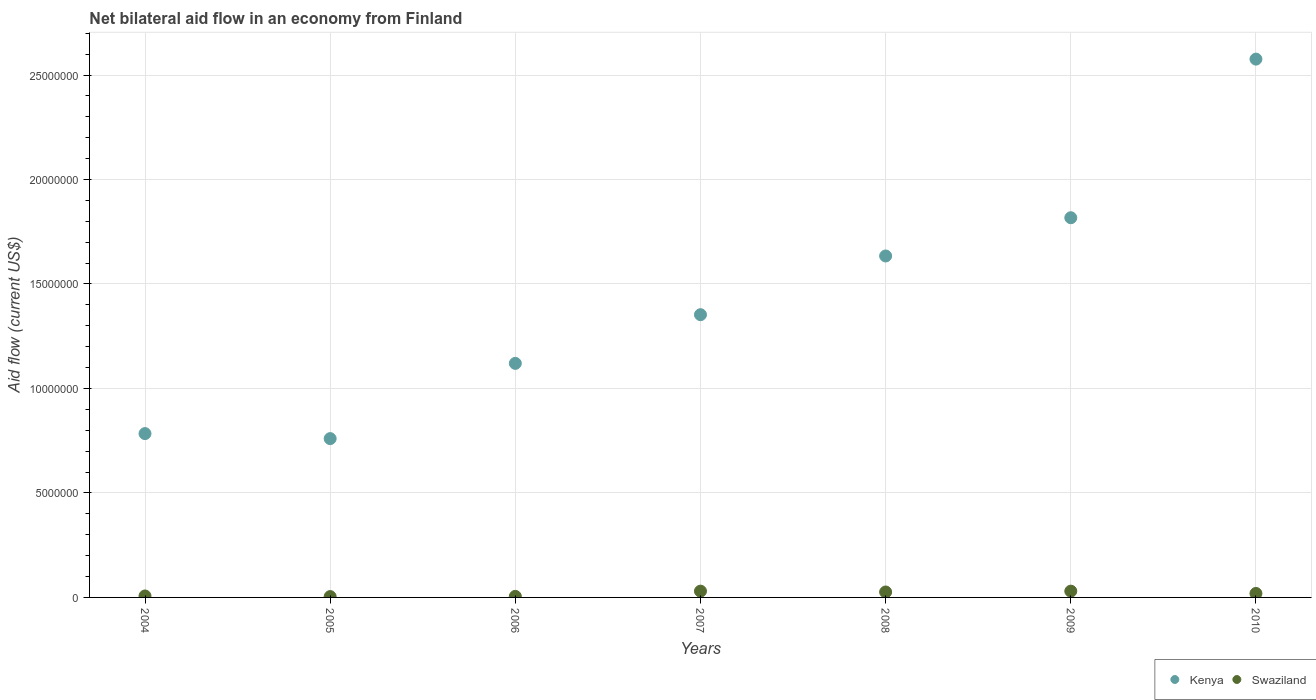Is the number of dotlines equal to the number of legend labels?
Provide a short and direct response. Yes. What is the net bilateral aid flow in Kenya in 2006?
Provide a succinct answer. 1.12e+07. Across all years, what is the minimum net bilateral aid flow in Kenya?
Provide a short and direct response. 7.60e+06. In which year was the net bilateral aid flow in Swaziland maximum?
Offer a terse response. 2007. What is the total net bilateral aid flow in Kenya in the graph?
Ensure brevity in your answer.  1.00e+08. What is the difference between the net bilateral aid flow in Swaziland in 2006 and that in 2008?
Ensure brevity in your answer.  -2.10e+05. What is the difference between the net bilateral aid flow in Kenya in 2005 and the net bilateral aid flow in Swaziland in 2010?
Your answer should be compact. 7.41e+06. What is the average net bilateral aid flow in Kenya per year?
Offer a very short reply. 1.43e+07. In the year 2010, what is the difference between the net bilateral aid flow in Kenya and net bilateral aid flow in Swaziland?
Your answer should be very brief. 2.56e+07. In how many years, is the net bilateral aid flow in Kenya greater than 19000000 US$?
Make the answer very short. 1. What is the ratio of the net bilateral aid flow in Swaziland in 2006 to that in 2010?
Make the answer very short. 0.26. Is the net bilateral aid flow in Kenya in 2005 less than that in 2010?
Offer a very short reply. Yes. Is the difference between the net bilateral aid flow in Kenya in 2007 and 2010 greater than the difference between the net bilateral aid flow in Swaziland in 2007 and 2010?
Offer a very short reply. No. What is the difference between the highest and the second highest net bilateral aid flow in Kenya?
Ensure brevity in your answer.  7.59e+06. What is the difference between the highest and the lowest net bilateral aid flow in Kenya?
Keep it short and to the point. 1.82e+07. In how many years, is the net bilateral aid flow in Swaziland greater than the average net bilateral aid flow in Swaziland taken over all years?
Offer a very short reply. 4. Is the sum of the net bilateral aid flow in Swaziland in 2005 and 2006 greater than the maximum net bilateral aid flow in Kenya across all years?
Your answer should be compact. No. Does the net bilateral aid flow in Kenya monotonically increase over the years?
Your answer should be compact. No. Is the net bilateral aid flow in Kenya strictly less than the net bilateral aid flow in Swaziland over the years?
Provide a succinct answer. No. How many dotlines are there?
Give a very brief answer. 2. Are the values on the major ticks of Y-axis written in scientific E-notation?
Your response must be concise. No. Does the graph contain any zero values?
Your answer should be very brief. No. How many legend labels are there?
Provide a short and direct response. 2. What is the title of the graph?
Make the answer very short. Net bilateral aid flow in an economy from Finland. What is the label or title of the X-axis?
Your answer should be very brief. Years. What is the label or title of the Y-axis?
Your answer should be very brief. Aid flow (current US$). What is the Aid flow (current US$) of Kenya in 2004?
Your response must be concise. 7.84e+06. What is the Aid flow (current US$) in Swaziland in 2004?
Give a very brief answer. 7.00e+04. What is the Aid flow (current US$) of Kenya in 2005?
Your answer should be compact. 7.60e+06. What is the Aid flow (current US$) in Swaziland in 2005?
Ensure brevity in your answer.  4.00e+04. What is the Aid flow (current US$) of Kenya in 2006?
Offer a terse response. 1.12e+07. What is the Aid flow (current US$) in Kenya in 2007?
Give a very brief answer. 1.35e+07. What is the Aid flow (current US$) of Kenya in 2008?
Offer a terse response. 1.63e+07. What is the Aid flow (current US$) in Swaziland in 2008?
Your response must be concise. 2.60e+05. What is the Aid flow (current US$) in Kenya in 2009?
Make the answer very short. 1.82e+07. What is the Aid flow (current US$) in Kenya in 2010?
Offer a very short reply. 2.58e+07. What is the Aid flow (current US$) of Swaziland in 2010?
Your response must be concise. 1.90e+05. Across all years, what is the maximum Aid flow (current US$) of Kenya?
Offer a very short reply. 2.58e+07. Across all years, what is the maximum Aid flow (current US$) of Swaziland?
Ensure brevity in your answer.  3.00e+05. Across all years, what is the minimum Aid flow (current US$) in Kenya?
Your response must be concise. 7.60e+06. What is the total Aid flow (current US$) of Kenya in the graph?
Keep it short and to the point. 1.00e+08. What is the total Aid flow (current US$) in Swaziland in the graph?
Ensure brevity in your answer.  1.21e+06. What is the difference between the Aid flow (current US$) in Kenya in 2004 and that in 2005?
Ensure brevity in your answer.  2.40e+05. What is the difference between the Aid flow (current US$) of Kenya in 2004 and that in 2006?
Offer a terse response. -3.36e+06. What is the difference between the Aid flow (current US$) of Kenya in 2004 and that in 2007?
Your response must be concise. -5.69e+06. What is the difference between the Aid flow (current US$) in Kenya in 2004 and that in 2008?
Give a very brief answer. -8.50e+06. What is the difference between the Aid flow (current US$) of Kenya in 2004 and that in 2009?
Offer a terse response. -1.03e+07. What is the difference between the Aid flow (current US$) of Swaziland in 2004 and that in 2009?
Your answer should be compact. -2.30e+05. What is the difference between the Aid flow (current US$) in Kenya in 2004 and that in 2010?
Provide a short and direct response. -1.79e+07. What is the difference between the Aid flow (current US$) in Swaziland in 2004 and that in 2010?
Your answer should be very brief. -1.20e+05. What is the difference between the Aid flow (current US$) of Kenya in 2005 and that in 2006?
Ensure brevity in your answer.  -3.60e+06. What is the difference between the Aid flow (current US$) of Swaziland in 2005 and that in 2006?
Provide a succinct answer. -10000. What is the difference between the Aid flow (current US$) in Kenya in 2005 and that in 2007?
Offer a terse response. -5.93e+06. What is the difference between the Aid flow (current US$) in Swaziland in 2005 and that in 2007?
Make the answer very short. -2.60e+05. What is the difference between the Aid flow (current US$) of Kenya in 2005 and that in 2008?
Give a very brief answer. -8.74e+06. What is the difference between the Aid flow (current US$) in Kenya in 2005 and that in 2009?
Offer a terse response. -1.06e+07. What is the difference between the Aid flow (current US$) in Kenya in 2005 and that in 2010?
Your answer should be compact. -1.82e+07. What is the difference between the Aid flow (current US$) of Kenya in 2006 and that in 2007?
Keep it short and to the point. -2.33e+06. What is the difference between the Aid flow (current US$) in Swaziland in 2006 and that in 2007?
Ensure brevity in your answer.  -2.50e+05. What is the difference between the Aid flow (current US$) of Kenya in 2006 and that in 2008?
Provide a succinct answer. -5.14e+06. What is the difference between the Aid flow (current US$) of Swaziland in 2006 and that in 2008?
Your answer should be very brief. -2.10e+05. What is the difference between the Aid flow (current US$) of Kenya in 2006 and that in 2009?
Give a very brief answer. -6.97e+06. What is the difference between the Aid flow (current US$) in Kenya in 2006 and that in 2010?
Offer a terse response. -1.46e+07. What is the difference between the Aid flow (current US$) of Kenya in 2007 and that in 2008?
Give a very brief answer. -2.81e+06. What is the difference between the Aid flow (current US$) in Swaziland in 2007 and that in 2008?
Give a very brief answer. 4.00e+04. What is the difference between the Aid flow (current US$) of Kenya in 2007 and that in 2009?
Ensure brevity in your answer.  -4.64e+06. What is the difference between the Aid flow (current US$) of Swaziland in 2007 and that in 2009?
Offer a very short reply. 0. What is the difference between the Aid flow (current US$) in Kenya in 2007 and that in 2010?
Your response must be concise. -1.22e+07. What is the difference between the Aid flow (current US$) of Kenya in 2008 and that in 2009?
Offer a terse response. -1.83e+06. What is the difference between the Aid flow (current US$) in Kenya in 2008 and that in 2010?
Give a very brief answer. -9.42e+06. What is the difference between the Aid flow (current US$) in Swaziland in 2008 and that in 2010?
Give a very brief answer. 7.00e+04. What is the difference between the Aid flow (current US$) of Kenya in 2009 and that in 2010?
Give a very brief answer. -7.59e+06. What is the difference between the Aid flow (current US$) of Kenya in 2004 and the Aid flow (current US$) of Swaziland in 2005?
Your response must be concise. 7.80e+06. What is the difference between the Aid flow (current US$) of Kenya in 2004 and the Aid flow (current US$) of Swaziland in 2006?
Your answer should be very brief. 7.79e+06. What is the difference between the Aid flow (current US$) in Kenya in 2004 and the Aid flow (current US$) in Swaziland in 2007?
Provide a short and direct response. 7.54e+06. What is the difference between the Aid flow (current US$) of Kenya in 2004 and the Aid flow (current US$) of Swaziland in 2008?
Provide a succinct answer. 7.58e+06. What is the difference between the Aid flow (current US$) of Kenya in 2004 and the Aid flow (current US$) of Swaziland in 2009?
Your answer should be compact. 7.54e+06. What is the difference between the Aid flow (current US$) in Kenya in 2004 and the Aid flow (current US$) in Swaziland in 2010?
Ensure brevity in your answer.  7.65e+06. What is the difference between the Aid flow (current US$) of Kenya in 2005 and the Aid flow (current US$) of Swaziland in 2006?
Offer a terse response. 7.55e+06. What is the difference between the Aid flow (current US$) of Kenya in 2005 and the Aid flow (current US$) of Swaziland in 2007?
Keep it short and to the point. 7.30e+06. What is the difference between the Aid flow (current US$) of Kenya in 2005 and the Aid flow (current US$) of Swaziland in 2008?
Make the answer very short. 7.34e+06. What is the difference between the Aid flow (current US$) in Kenya in 2005 and the Aid flow (current US$) in Swaziland in 2009?
Your answer should be very brief. 7.30e+06. What is the difference between the Aid flow (current US$) in Kenya in 2005 and the Aid flow (current US$) in Swaziland in 2010?
Your response must be concise. 7.41e+06. What is the difference between the Aid flow (current US$) in Kenya in 2006 and the Aid flow (current US$) in Swaziland in 2007?
Keep it short and to the point. 1.09e+07. What is the difference between the Aid flow (current US$) of Kenya in 2006 and the Aid flow (current US$) of Swaziland in 2008?
Give a very brief answer. 1.09e+07. What is the difference between the Aid flow (current US$) of Kenya in 2006 and the Aid flow (current US$) of Swaziland in 2009?
Your answer should be compact. 1.09e+07. What is the difference between the Aid flow (current US$) in Kenya in 2006 and the Aid flow (current US$) in Swaziland in 2010?
Offer a terse response. 1.10e+07. What is the difference between the Aid flow (current US$) in Kenya in 2007 and the Aid flow (current US$) in Swaziland in 2008?
Provide a short and direct response. 1.33e+07. What is the difference between the Aid flow (current US$) of Kenya in 2007 and the Aid flow (current US$) of Swaziland in 2009?
Keep it short and to the point. 1.32e+07. What is the difference between the Aid flow (current US$) of Kenya in 2007 and the Aid flow (current US$) of Swaziland in 2010?
Your response must be concise. 1.33e+07. What is the difference between the Aid flow (current US$) of Kenya in 2008 and the Aid flow (current US$) of Swaziland in 2009?
Offer a terse response. 1.60e+07. What is the difference between the Aid flow (current US$) in Kenya in 2008 and the Aid flow (current US$) in Swaziland in 2010?
Provide a succinct answer. 1.62e+07. What is the difference between the Aid flow (current US$) of Kenya in 2009 and the Aid flow (current US$) of Swaziland in 2010?
Provide a succinct answer. 1.80e+07. What is the average Aid flow (current US$) in Kenya per year?
Your answer should be compact. 1.43e+07. What is the average Aid flow (current US$) of Swaziland per year?
Ensure brevity in your answer.  1.73e+05. In the year 2004, what is the difference between the Aid flow (current US$) in Kenya and Aid flow (current US$) in Swaziland?
Offer a terse response. 7.77e+06. In the year 2005, what is the difference between the Aid flow (current US$) in Kenya and Aid flow (current US$) in Swaziland?
Offer a terse response. 7.56e+06. In the year 2006, what is the difference between the Aid flow (current US$) in Kenya and Aid flow (current US$) in Swaziland?
Your answer should be compact. 1.12e+07. In the year 2007, what is the difference between the Aid flow (current US$) of Kenya and Aid flow (current US$) of Swaziland?
Your answer should be very brief. 1.32e+07. In the year 2008, what is the difference between the Aid flow (current US$) of Kenya and Aid flow (current US$) of Swaziland?
Ensure brevity in your answer.  1.61e+07. In the year 2009, what is the difference between the Aid flow (current US$) in Kenya and Aid flow (current US$) in Swaziland?
Keep it short and to the point. 1.79e+07. In the year 2010, what is the difference between the Aid flow (current US$) of Kenya and Aid flow (current US$) of Swaziland?
Provide a succinct answer. 2.56e+07. What is the ratio of the Aid flow (current US$) in Kenya in 2004 to that in 2005?
Your answer should be compact. 1.03. What is the ratio of the Aid flow (current US$) in Kenya in 2004 to that in 2006?
Give a very brief answer. 0.7. What is the ratio of the Aid flow (current US$) in Swaziland in 2004 to that in 2006?
Offer a very short reply. 1.4. What is the ratio of the Aid flow (current US$) in Kenya in 2004 to that in 2007?
Give a very brief answer. 0.58. What is the ratio of the Aid flow (current US$) of Swaziland in 2004 to that in 2007?
Offer a terse response. 0.23. What is the ratio of the Aid flow (current US$) in Kenya in 2004 to that in 2008?
Make the answer very short. 0.48. What is the ratio of the Aid flow (current US$) of Swaziland in 2004 to that in 2008?
Make the answer very short. 0.27. What is the ratio of the Aid flow (current US$) in Kenya in 2004 to that in 2009?
Keep it short and to the point. 0.43. What is the ratio of the Aid flow (current US$) in Swaziland in 2004 to that in 2009?
Your answer should be compact. 0.23. What is the ratio of the Aid flow (current US$) of Kenya in 2004 to that in 2010?
Your response must be concise. 0.3. What is the ratio of the Aid flow (current US$) of Swaziland in 2004 to that in 2010?
Make the answer very short. 0.37. What is the ratio of the Aid flow (current US$) of Kenya in 2005 to that in 2006?
Offer a very short reply. 0.68. What is the ratio of the Aid flow (current US$) in Swaziland in 2005 to that in 2006?
Provide a succinct answer. 0.8. What is the ratio of the Aid flow (current US$) in Kenya in 2005 to that in 2007?
Your answer should be compact. 0.56. What is the ratio of the Aid flow (current US$) of Swaziland in 2005 to that in 2007?
Provide a succinct answer. 0.13. What is the ratio of the Aid flow (current US$) of Kenya in 2005 to that in 2008?
Your response must be concise. 0.47. What is the ratio of the Aid flow (current US$) of Swaziland in 2005 to that in 2008?
Ensure brevity in your answer.  0.15. What is the ratio of the Aid flow (current US$) of Kenya in 2005 to that in 2009?
Make the answer very short. 0.42. What is the ratio of the Aid flow (current US$) of Swaziland in 2005 to that in 2009?
Your response must be concise. 0.13. What is the ratio of the Aid flow (current US$) of Kenya in 2005 to that in 2010?
Offer a very short reply. 0.29. What is the ratio of the Aid flow (current US$) of Swaziland in 2005 to that in 2010?
Your answer should be very brief. 0.21. What is the ratio of the Aid flow (current US$) in Kenya in 2006 to that in 2007?
Make the answer very short. 0.83. What is the ratio of the Aid flow (current US$) of Kenya in 2006 to that in 2008?
Make the answer very short. 0.69. What is the ratio of the Aid flow (current US$) in Swaziland in 2006 to that in 2008?
Keep it short and to the point. 0.19. What is the ratio of the Aid flow (current US$) of Kenya in 2006 to that in 2009?
Offer a terse response. 0.62. What is the ratio of the Aid flow (current US$) of Swaziland in 2006 to that in 2009?
Provide a succinct answer. 0.17. What is the ratio of the Aid flow (current US$) in Kenya in 2006 to that in 2010?
Provide a succinct answer. 0.43. What is the ratio of the Aid flow (current US$) of Swaziland in 2006 to that in 2010?
Keep it short and to the point. 0.26. What is the ratio of the Aid flow (current US$) in Kenya in 2007 to that in 2008?
Provide a succinct answer. 0.83. What is the ratio of the Aid flow (current US$) of Swaziland in 2007 to that in 2008?
Ensure brevity in your answer.  1.15. What is the ratio of the Aid flow (current US$) of Kenya in 2007 to that in 2009?
Keep it short and to the point. 0.74. What is the ratio of the Aid flow (current US$) of Swaziland in 2007 to that in 2009?
Your answer should be very brief. 1. What is the ratio of the Aid flow (current US$) of Kenya in 2007 to that in 2010?
Provide a succinct answer. 0.53. What is the ratio of the Aid flow (current US$) in Swaziland in 2007 to that in 2010?
Provide a succinct answer. 1.58. What is the ratio of the Aid flow (current US$) of Kenya in 2008 to that in 2009?
Your answer should be very brief. 0.9. What is the ratio of the Aid flow (current US$) of Swaziland in 2008 to that in 2009?
Give a very brief answer. 0.87. What is the ratio of the Aid flow (current US$) in Kenya in 2008 to that in 2010?
Your answer should be compact. 0.63. What is the ratio of the Aid flow (current US$) in Swaziland in 2008 to that in 2010?
Your answer should be compact. 1.37. What is the ratio of the Aid flow (current US$) in Kenya in 2009 to that in 2010?
Provide a short and direct response. 0.71. What is the ratio of the Aid flow (current US$) in Swaziland in 2009 to that in 2010?
Your answer should be very brief. 1.58. What is the difference between the highest and the second highest Aid flow (current US$) of Kenya?
Keep it short and to the point. 7.59e+06. What is the difference between the highest and the lowest Aid flow (current US$) in Kenya?
Your answer should be compact. 1.82e+07. What is the difference between the highest and the lowest Aid flow (current US$) in Swaziland?
Ensure brevity in your answer.  2.60e+05. 